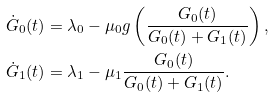Convert formula to latex. <formula><loc_0><loc_0><loc_500><loc_500>\dot { G } _ { 0 } ( t ) & = \lambda _ { 0 } - \mu _ { 0 } g \left ( \frac { G _ { 0 } ( t ) } { G _ { 0 } ( t ) + G _ { 1 } ( t ) } \right ) , \\ \dot { G } _ { 1 } ( t ) & = \lambda _ { 1 } - \mu _ { 1 } \frac { G _ { 0 } ( t ) } { G _ { 0 } ( t ) + G _ { 1 } ( t ) } .</formula> 